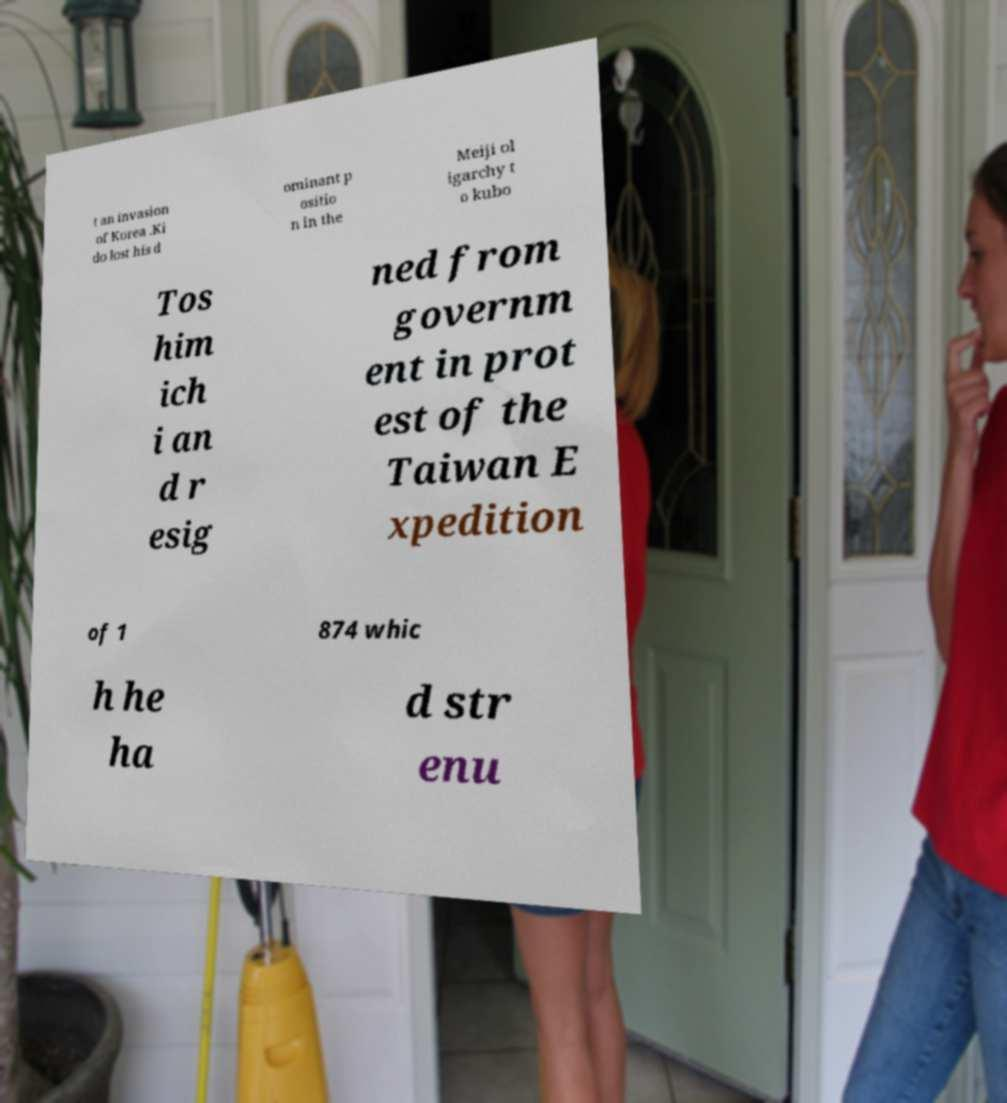Could you assist in decoding the text presented in this image and type it out clearly? t an invasion of Korea .Ki do lost his d ominant p ositio n in the Meiji ol igarchy t o kubo Tos him ich i an d r esig ned from governm ent in prot est of the Taiwan E xpedition of 1 874 whic h he ha d str enu 